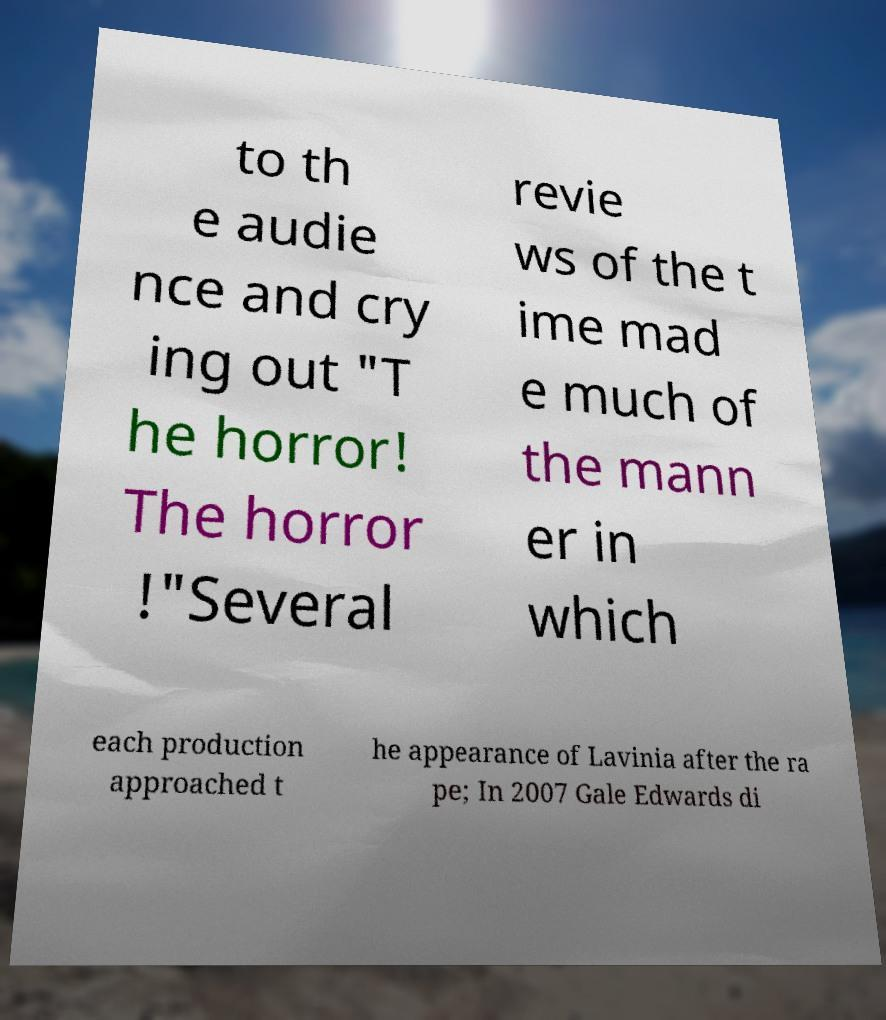Can you accurately transcribe the text from the provided image for me? to th e audie nce and cry ing out "T he horror! The horror !"Several revie ws of the t ime mad e much of the mann er in which each production approached t he appearance of Lavinia after the ra pe; In 2007 Gale Edwards di 